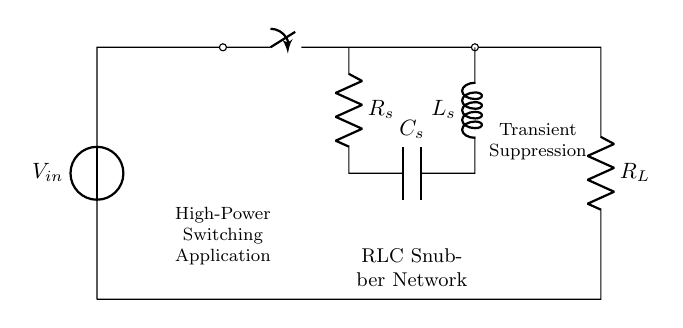What are the components used in this circuit? The components are a resistor, inductor, and capacitor, as indicated by the symbols. The circuit also includes a voltage source and a switch.
Answer: resistor, inductor, capacitor What is the role of the resistor in the RLC snubber network? The resistor dissipates energy, aiding in controlling the circuit's transient response and providing damping to reduce oscillations.
Answer: damping What is the function of the capacitor in this circuit? The capacitor stores energy temporarily, helping to suppress voltage spikes during transient events by absorbing excess energy.
Answer: energy absorption How many components are connected in series in the RLC network? There are three components (R, L, C) connected in series within the snubber part of the circuit.
Answer: three What is the voltage across the input node labeled as V_in? The voltage across V_in is unspecified in the diagram but can be defined as the source voltage connected to the circuit.
Answer: V_in What effect does the inductor have during a transient event? The inductor opposes changes in current due to its property of inductance, which helps to smooth out current fluctuations during fast switching.
Answer: current smoothing Why is this circuit specifically referred to as a snubber network? It is called a snubber network because it contains components designed to suppress transients, protecting sensitive devices from voltage or current spikes.
Answer: transient suppression 